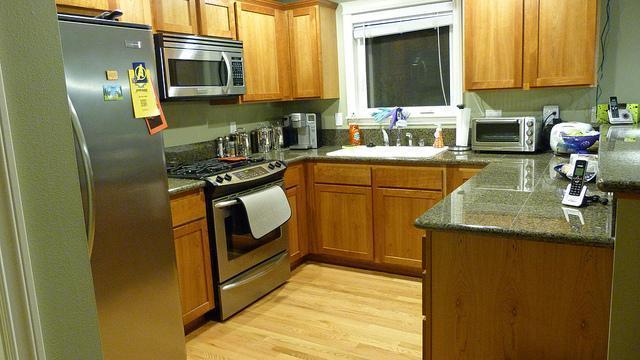How many ovens are in the picture?
Give a very brief answer. 2. How many cows are standing up?
Give a very brief answer. 0. 